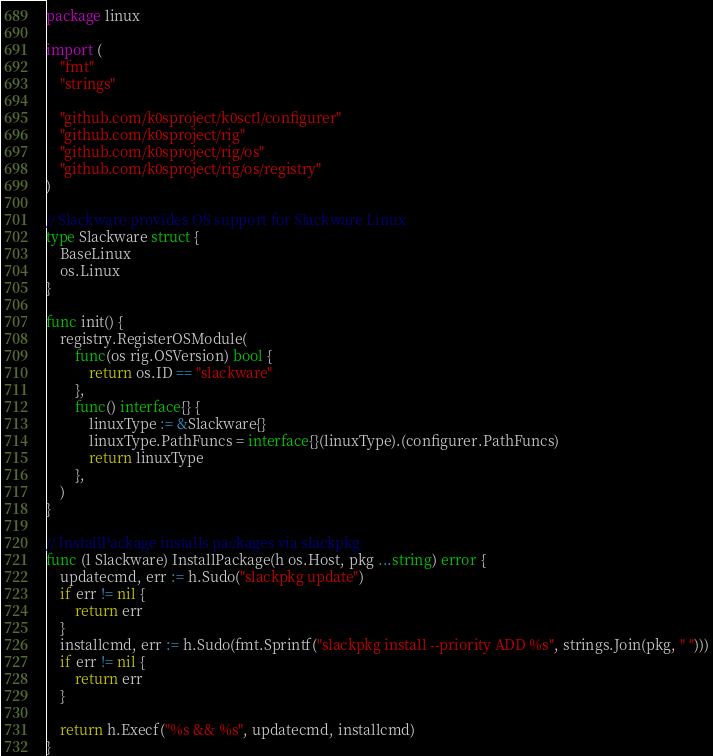Convert code to text. <code><loc_0><loc_0><loc_500><loc_500><_Go_>package linux

import (
	"fmt"
	"strings"

	"github.com/k0sproject/k0sctl/configurer"
	"github.com/k0sproject/rig"
	"github.com/k0sproject/rig/os"
	"github.com/k0sproject/rig/os/registry"
)

// Slackware provides OS support for Slackware Linux
type Slackware struct {
	BaseLinux
	os.Linux
}

func init() {
	registry.RegisterOSModule(
		func(os rig.OSVersion) bool {
			return os.ID == "slackware"
		},
		func() interface{} {
			linuxType := &Slackware{}
			linuxType.PathFuncs = interface{}(linuxType).(configurer.PathFuncs)
			return linuxType
		},
	)
}

// InstallPackage installs packages via slackpkg
func (l Slackware) InstallPackage(h os.Host, pkg ...string) error {
	updatecmd, err := h.Sudo("slackpkg update")
	if err != nil {
		return err
	}
	installcmd, err := h.Sudo(fmt.Sprintf("slackpkg install --priority ADD %s", strings.Join(pkg, " ")))
	if err != nil {
		return err
	}

	return h.Execf("%s && %s", updatecmd, installcmd)
}
</code> 